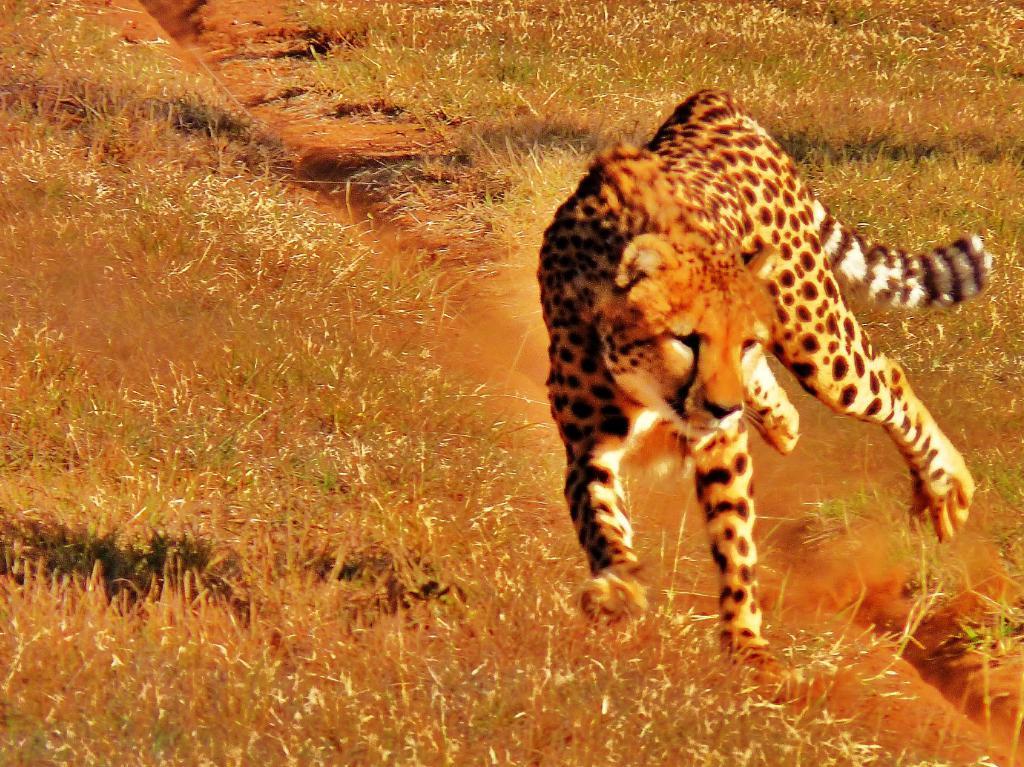Can you describe this image briefly? In this picture we can see a cheetah running on the grass. 